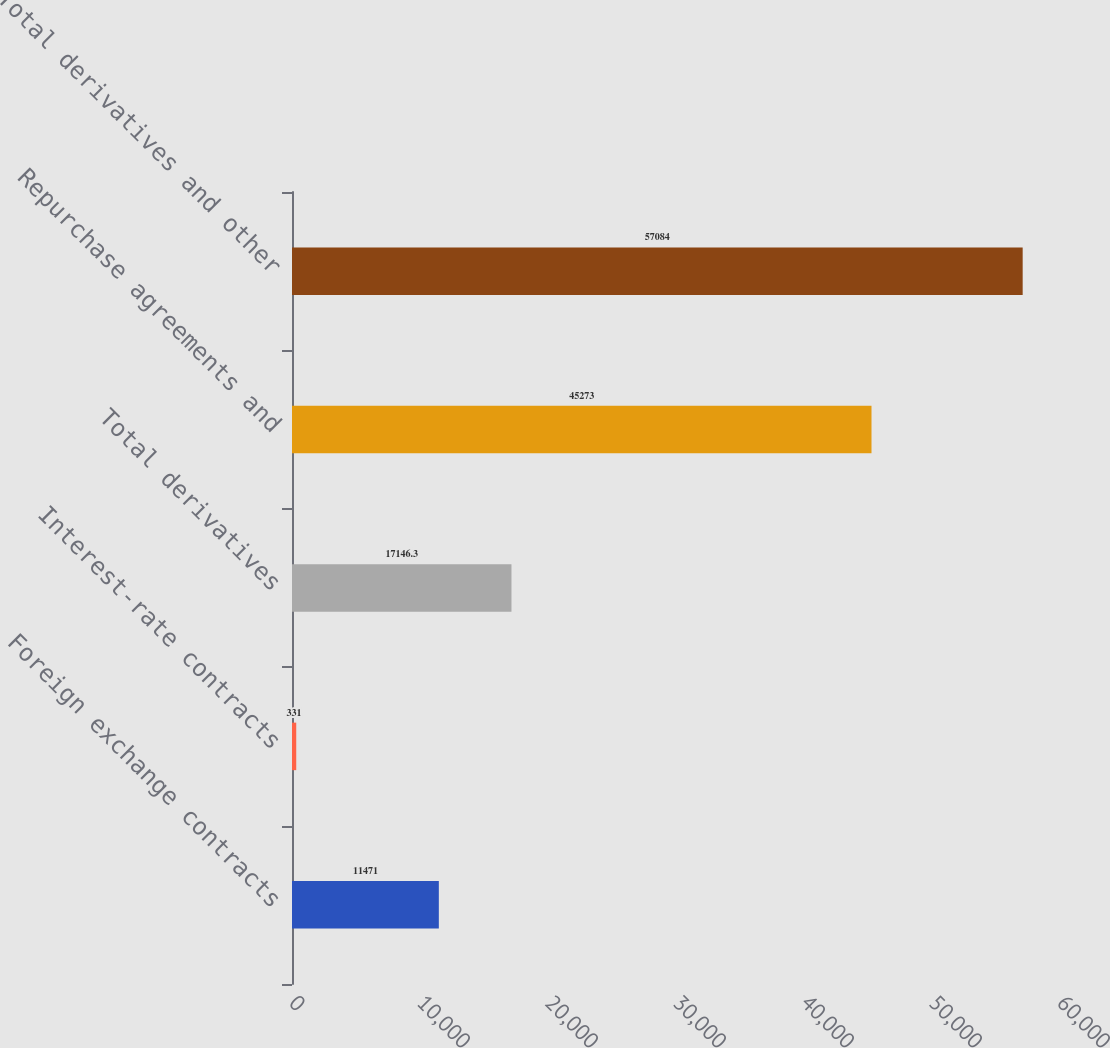Convert chart. <chart><loc_0><loc_0><loc_500><loc_500><bar_chart><fcel>Foreign exchange contracts<fcel>Interest-rate contracts<fcel>Total derivatives<fcel>Repurchase agreements and<fcel>Total derivatives and other<nl><fcel>11471<fcel>331<fcel>17146.3<fcel>45273<fcel>57084<nl></chart> 